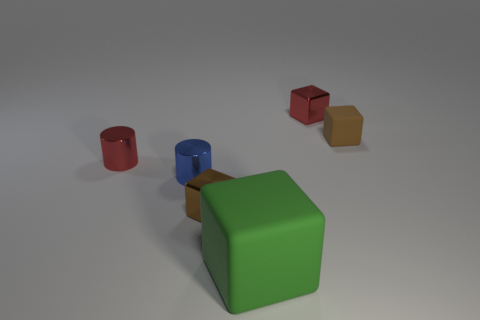What time of day does it seem to be, judging by the lighting in the image? The lighting in the image is soft and diffused, without any hard shadows or strong highlights that could suggest bright sunlight. This type of lighting doesn't indicate a specific time of day, as it's likely produced in a controlled indoor environment, perhaps a studio setup with artificial lighting.  Is there any indication of the size of these objects relative to one another? Indeed, there are some indications of relative size. The green cube appears to be the largest object in the collection, followed by the blue cube, and then the red cylinder. The smallest object seems to be the tiny red cube. The differences in size could be used to discuss proportions and scaling. 